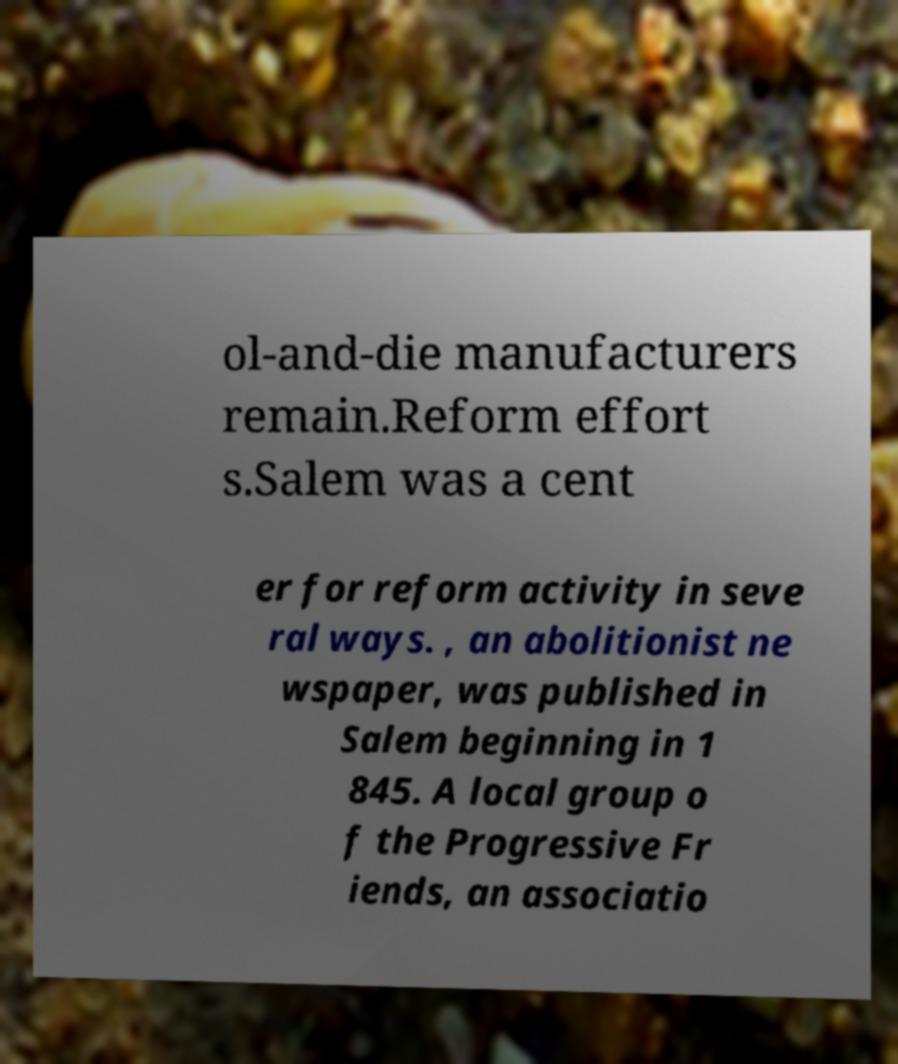I need the written content from this picture converted into text. Can you do that? ol-and-die manufacturers remain.Reform effort s.Salem was a cent er for reform activity in seve ral ways. , an abolitionist ne wspaper, was published in Salem beginning in 1 845. A local group o f the Progressive Fr iends, an associatio 